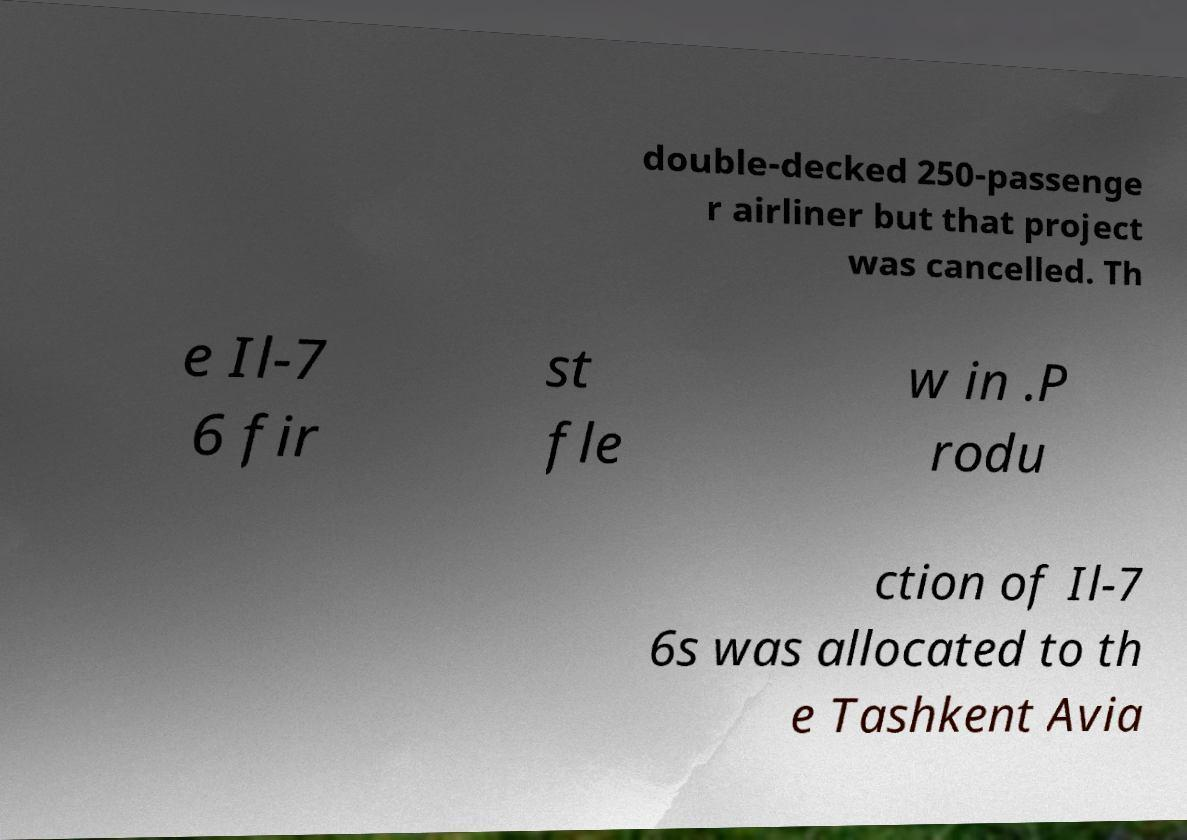Could you assist in decoding the text presented in this image and type it out clearly? double-decked 250-passenge r airliner but that project was cancelled. Th e Il-7 6 fir st fle w in .P rodu ction of Il-7 6s was allocated to th e Tashkent Avia 